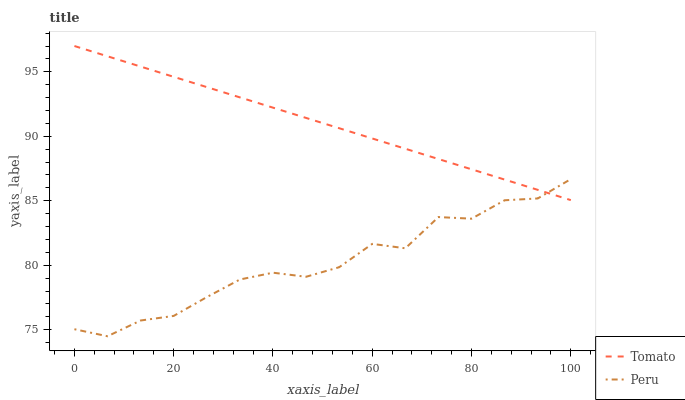Does Peru have the maximum area under the curve?
Answer yes or no. No. Is Peru the smoothest?
Answer yes or no. No. Does Peru have the highest value?
Answer yes or no. No. 